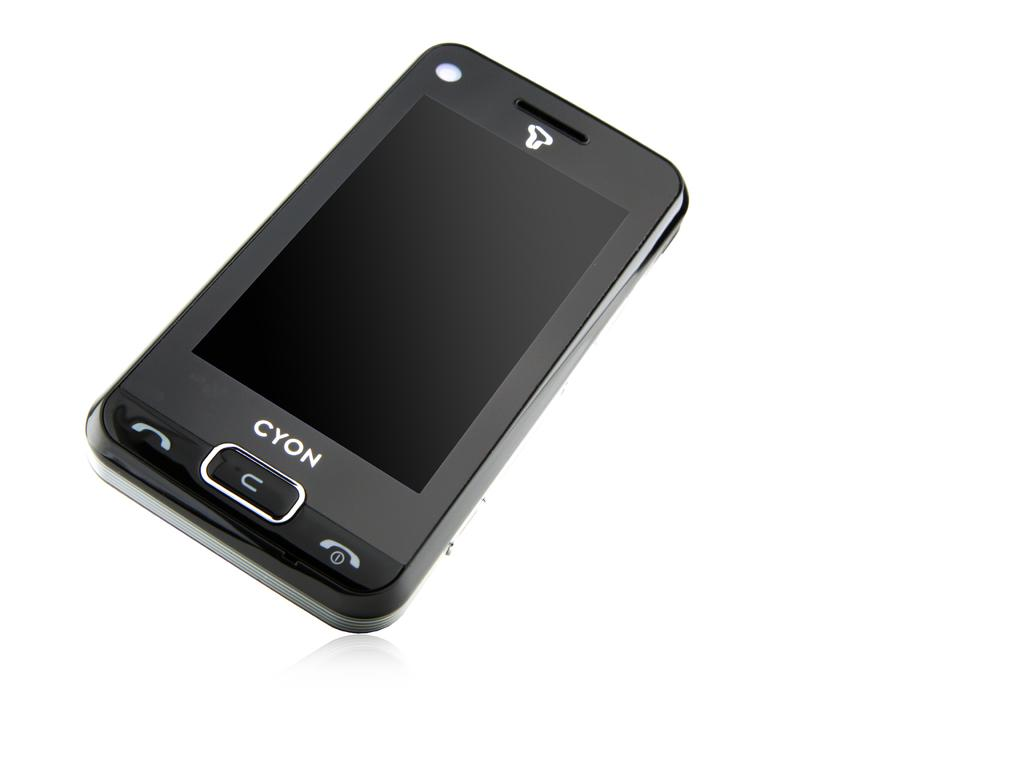<image>
Share a concise interpretation of the image provided. Black Cyon cellphone in front of a white background. 